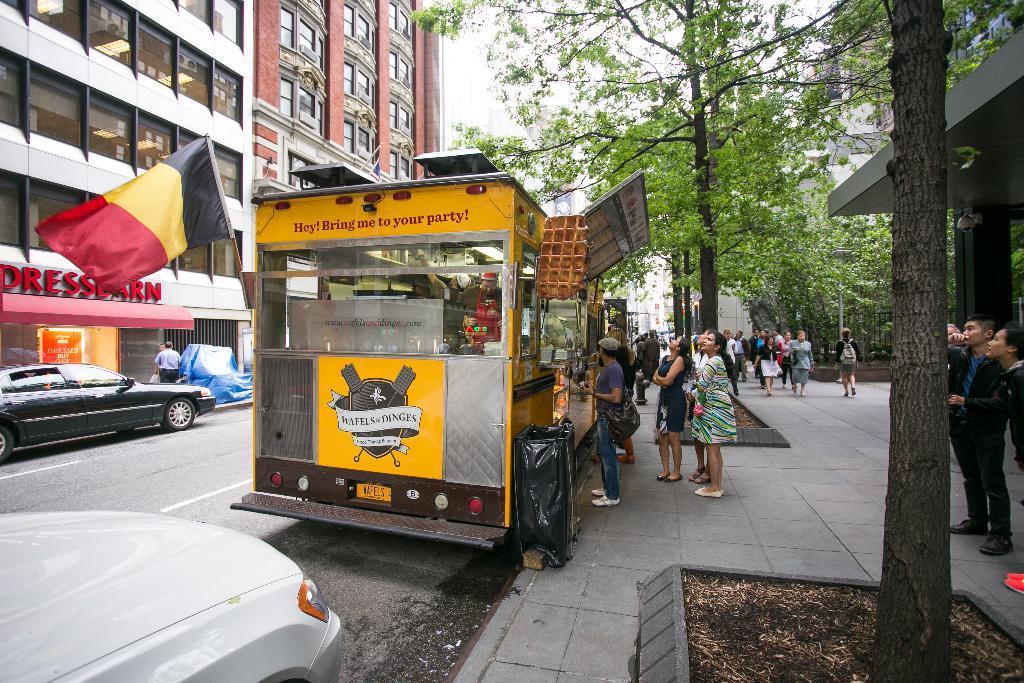Describe this image in one or two sentences. In the center of the image there are vehicles on the road. On the right side of the image there are people walking on the pavement. There are trees. There is a metal fence. In the background of the image there are buildings and sky. 